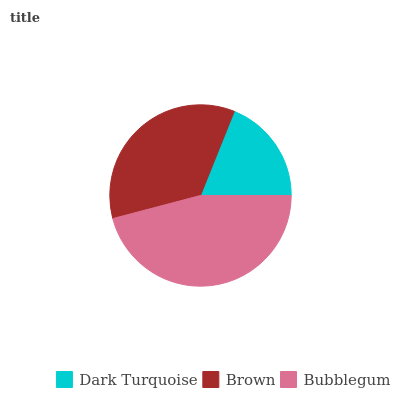Is Dark Turquoise the minimum?
Answer yes or no. Yes. Is Bubblegum the maximum?
Answer yes or no. Yes. Is Brown the minimum?
Answer yes or no. No. Is Brown the maximum?
Answer yes or no. No. Is Brown greater than Dark Turquoise?
Answer yes or no. Yes. Is Dark Turquoise less than Brown?
Answer yes or no. Yes. Is Dark Turquoise greater than Brown?
Answer yes or no. No. Is Brown less than Dark Turquoise?
Answer yes or no. No. Is Brown the high median?
Answer yes or no. Yes. Is Brown the low median?
Answer yes or no. Yes. Is Dark Turquoise the high median?
Answer yes or no. No. Is Bubblegum the low median?
Answer yes or no. No. 